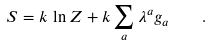<formula> <loc_0><loc_0><loc_500><loc_500>S = k \, \ln Z + k \sum _ { a } \lambda ^ { a } g _ { a } \quad .</formula> 